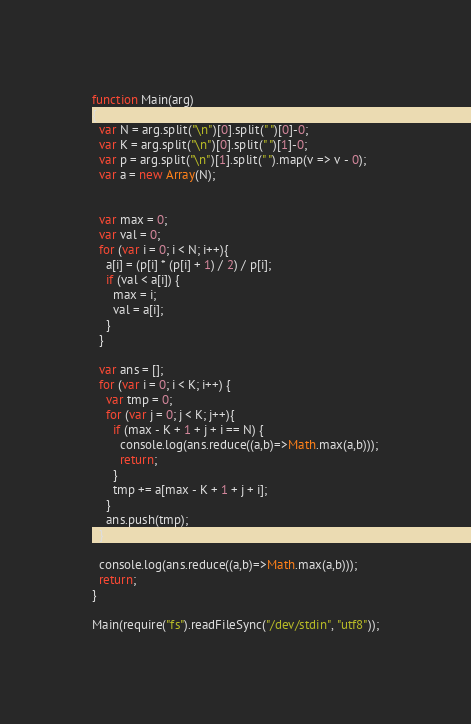Convert code to text. <code><loc_0><loc_0><loc_500><loc_500><_JavaScript_>
function Main(arg)
{
  var N = arg.split("\n")[0].split(" ")[0]-0;
  var K = arg.split("\n")[0].split(" ")[1]-0;
  var p = arg.split("\n")[1].split(" ").map(v => v - 0);
  var a = new Array(N);


  var max = 0;
  var val = 0;
  for (var i = 0; i < N; i++){
    a[i] = (p[i] * (p[i] + 1) / 2) / p[i];
    if (val < a[i]) {
      max = i;
      val = a[i];
    }
  }

  var ans = [];
  for (var i = 0; i < K; i++) {
    var tmp = 0;
    for (var j = 0; j < K; j++){
      if (max - K + 1 + j + i == N) {
        console.log(ans.reduce((a,b)=>Math.max(a,b)));
        return;
      }
      tmp += a[max - K + 1 + j + i];
    }
    ans.push(tmp);
  }

  console.log(ans.reduce((a,b)=>Math.max(a,b)));
  return;
}

Main(require("fs").readFileSync("/dev/stdin", "utf8"));</code> 